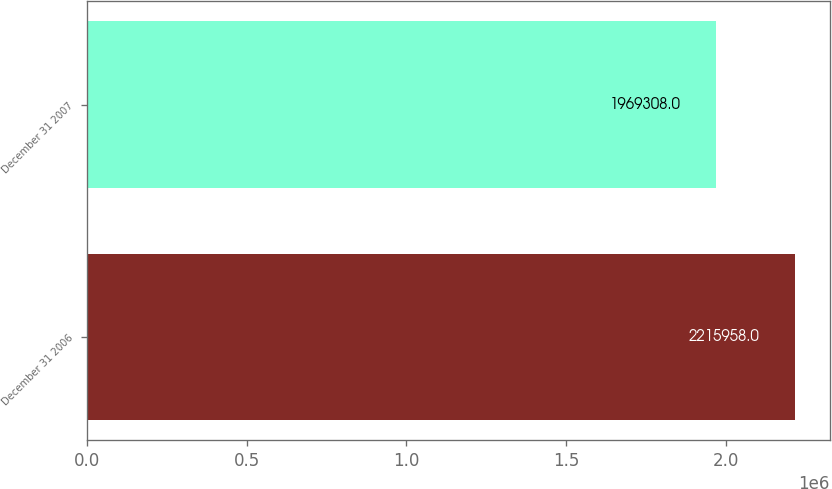Convert chart to OTSL. <chart><loc_0><loc_0><loc_500><loc_500><bar_chart><fcel>December 31 2006<fcel>December 31 2007<nl><fcel>2.21596e+06<fcel>1.96931e+06<nl></chart> 